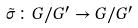Convert formula to latex. <formula><loc_0><loc_0><loc_500><loc_500>\tilde { \sigma } \colon G / G ^ { \prime } \rightarrow G / G ^ { \prime }</formula> 